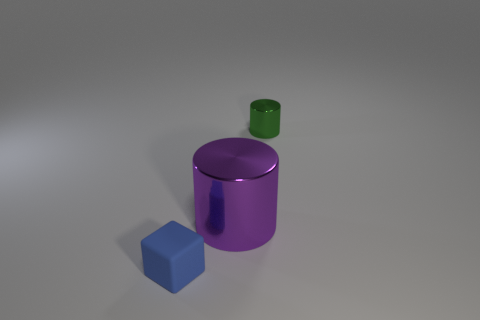There is a green cylinder; are there any objects on the right side of it?
Offer a very short reply. No. What is the color of the small object behind the blue thing?
Your response must be concise. Green. The tiny object to the left of the cylinder on the left side of the tiny metal cylinder is made of what material?
Provide a short and direct response. Rubber. Are there fewer blue rubber cubes to the right of the tiny metal object than large metallic cylinders behind the tiny matte object?
Offer a terse response. Yes. What number of yellow objects are either small shiny cylinders or shiny things?
Your answer should be very brief. 0. Are there the same number of small green objects that are to the right of the blue block and blocks?
Ensure brevity in your answer.  Yes. How many things are either tiny rubber things or things on the right side of the tiny blue object?
Your answer should be compact. 3. Is the color of the big shiny cylinder the same as the small rubber object?
Keep it short and to the point. No. Is there a large yellow thing made of the same material as the large purple cylinder?
Your answer should be very brief. No. What is the color of the other thing that is the same shape as the tiny green thing?
Offer a terse response. Purple. 